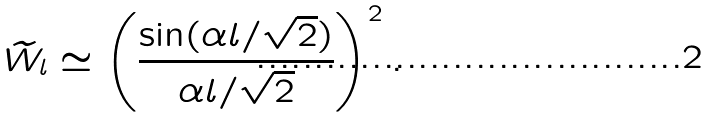<formula> <loc_0><loc_0><loc_500><loc_500>\widetilde { W } _ { l } \simeq \left ( \frac { \sin ( \alpha l / \sqrt { 2 } ) } { \alpha l / \sqrt { 2 } } \right ) ^ { 2 } .</formula> 